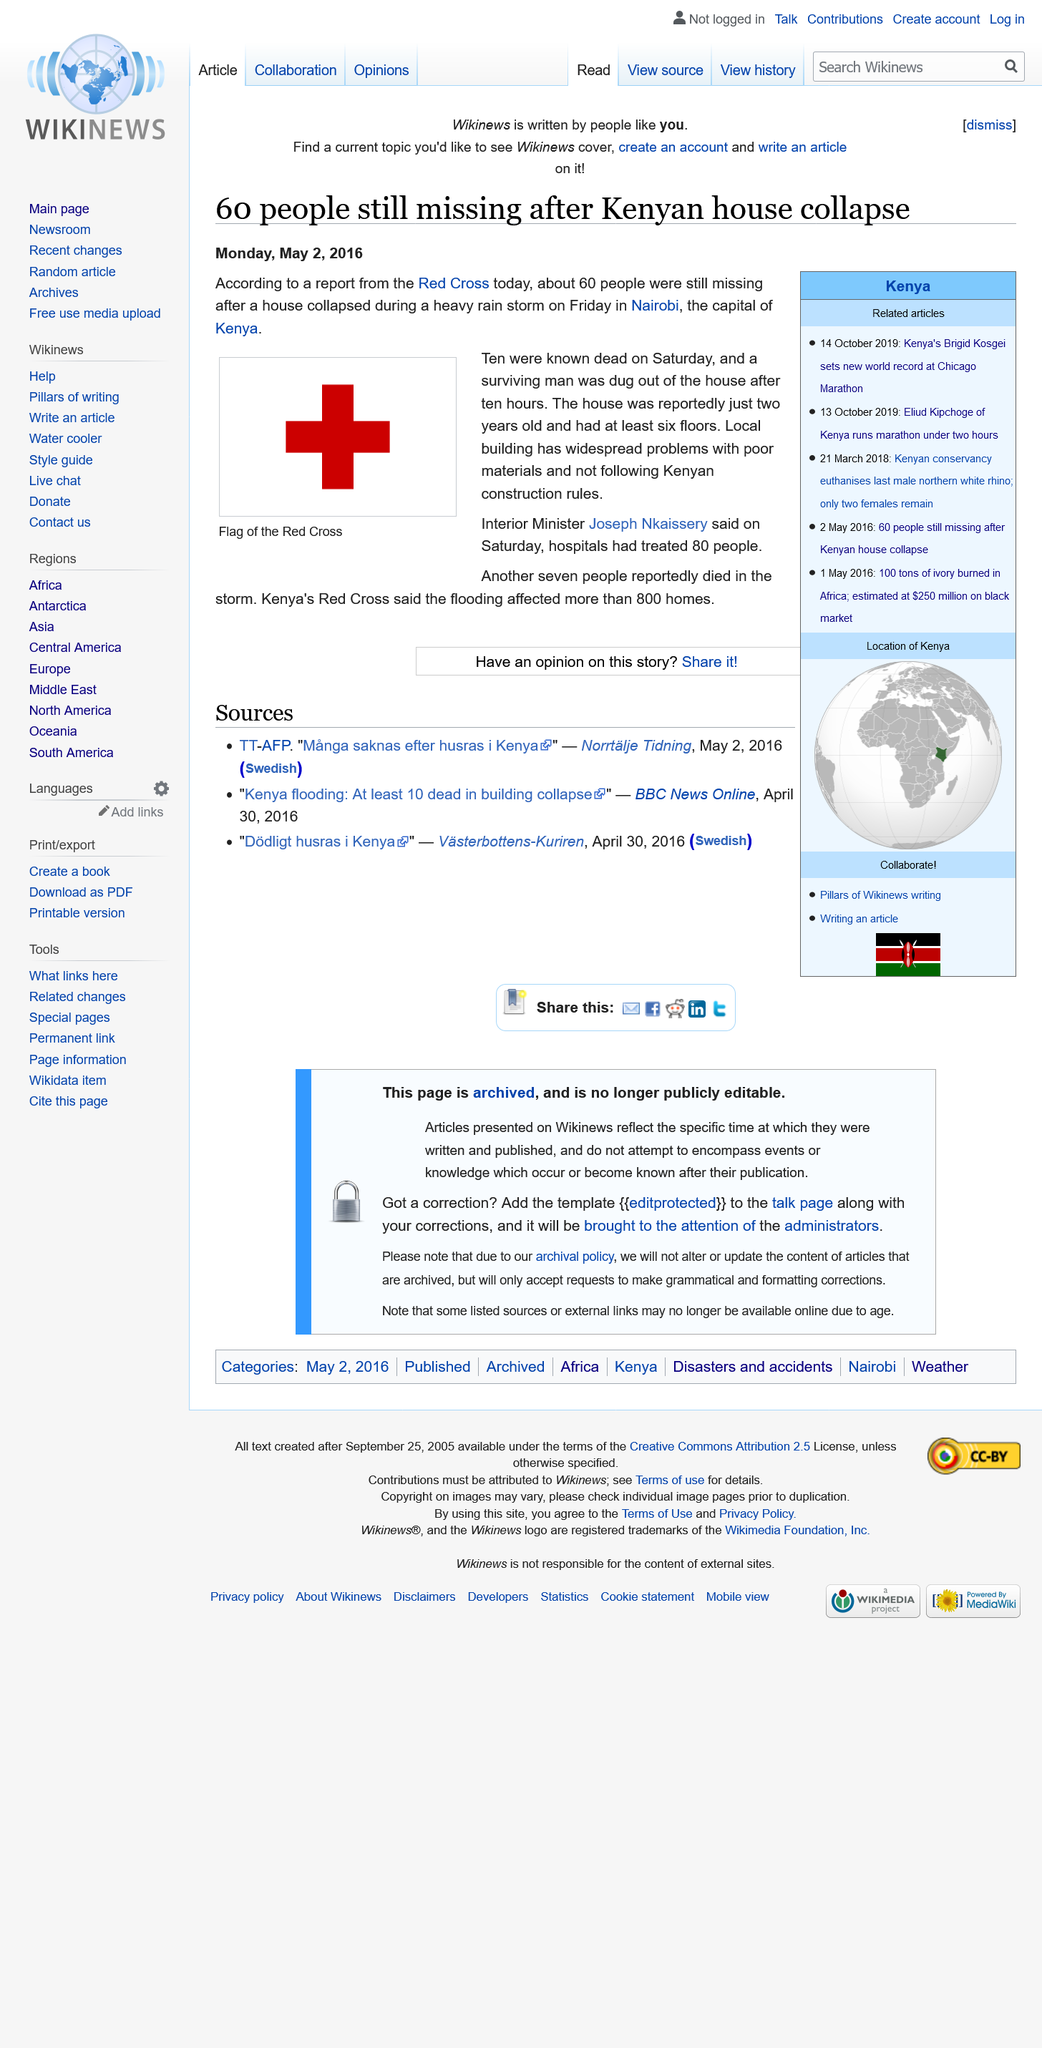List a handful of essential elements in this visual. According to the Interior Minister, the hospital had treated 80 people as of the time of the incident. The heavy rain in Nairobi, the capital of Kenya, caused a house to collapse, resulting in casualties and damage to the surrounding area. The Red Cross reported that approximately 60 people were still missing after a house collapsed. 